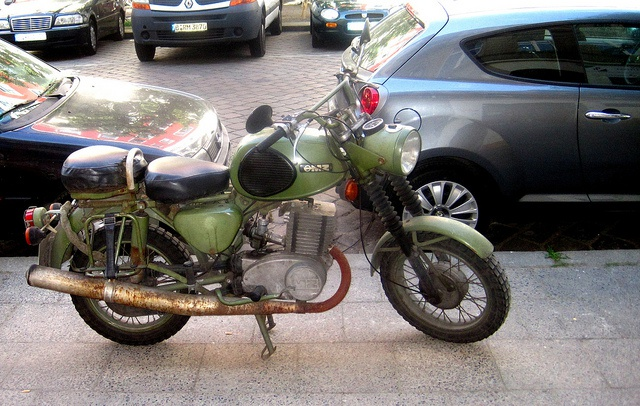Describe the objects in this image and their specific colors. I can see motorcycle in white, black, gray, darkgreen, and darkgray tones, car in white, black, gray, and darkgray tones, car in white, black, darkgray, and lightpink tones, truck in white, black, and gray tones, and car in white, black, and gray tones in this image. 